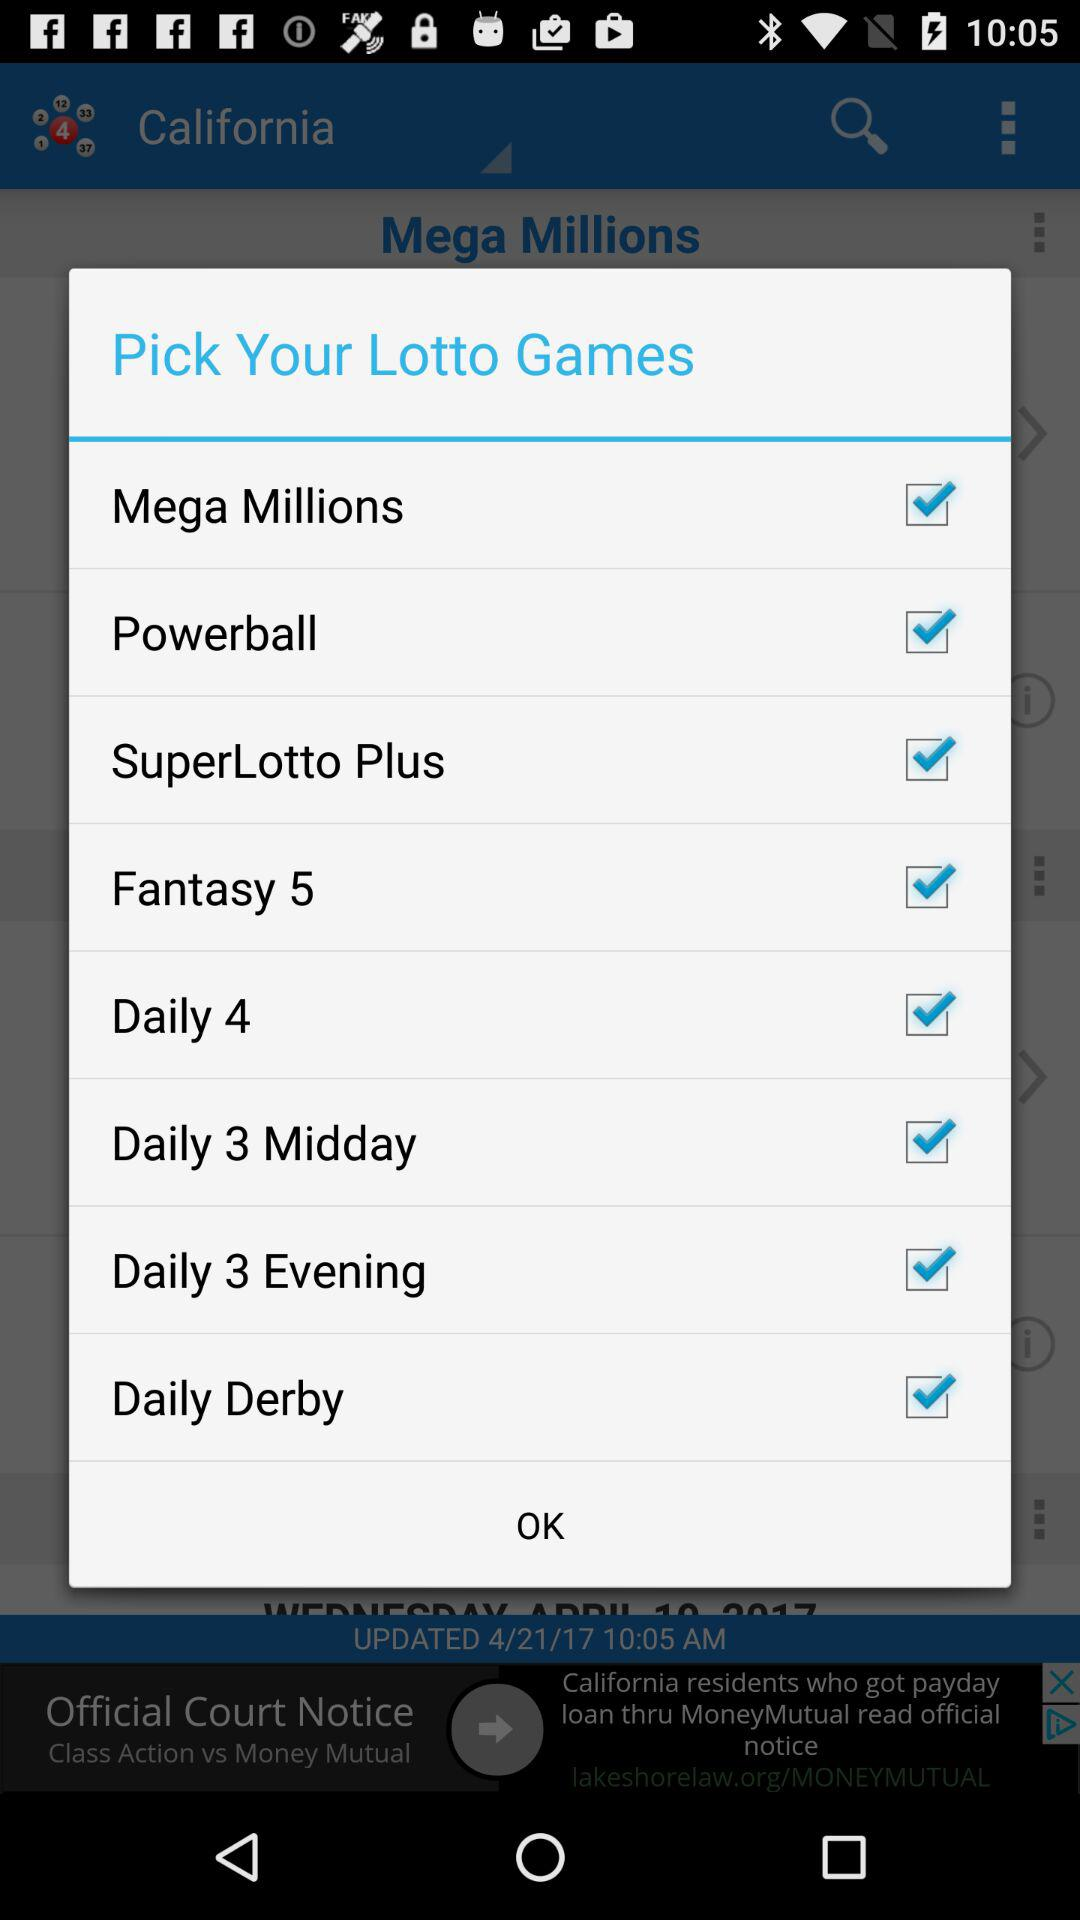Which country is mentioned to play Mega Million Lotto Game?
When the provided information is insufficient, respond with <no answer>. <no answer> 